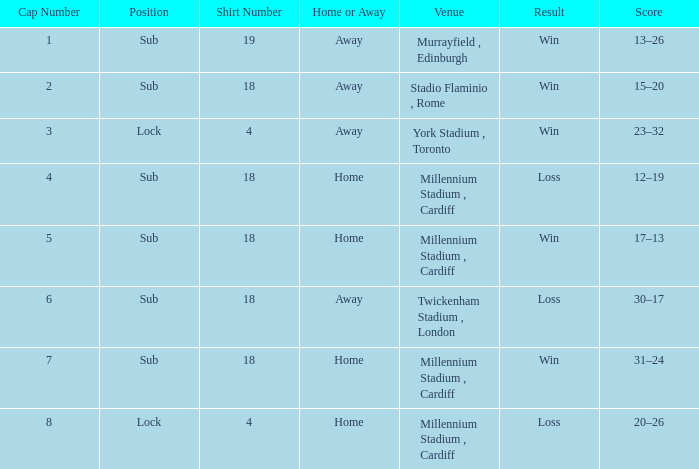What is the score of the victory that occurred on november 13, 2009? 17–13. 